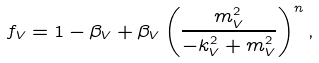Convert formula to latex. <formula><loc_0><loc_0><loc_500><loc_500>f _ { V } = 1 - \beta _ { V } + \beta _ { V } \left ( \frac { m _ { V } ^ { 2 } } { - k _ { V } ^ { 2 } + m _ { V } ^ { 2 } } \right ) ^ { n } ,</formula> 